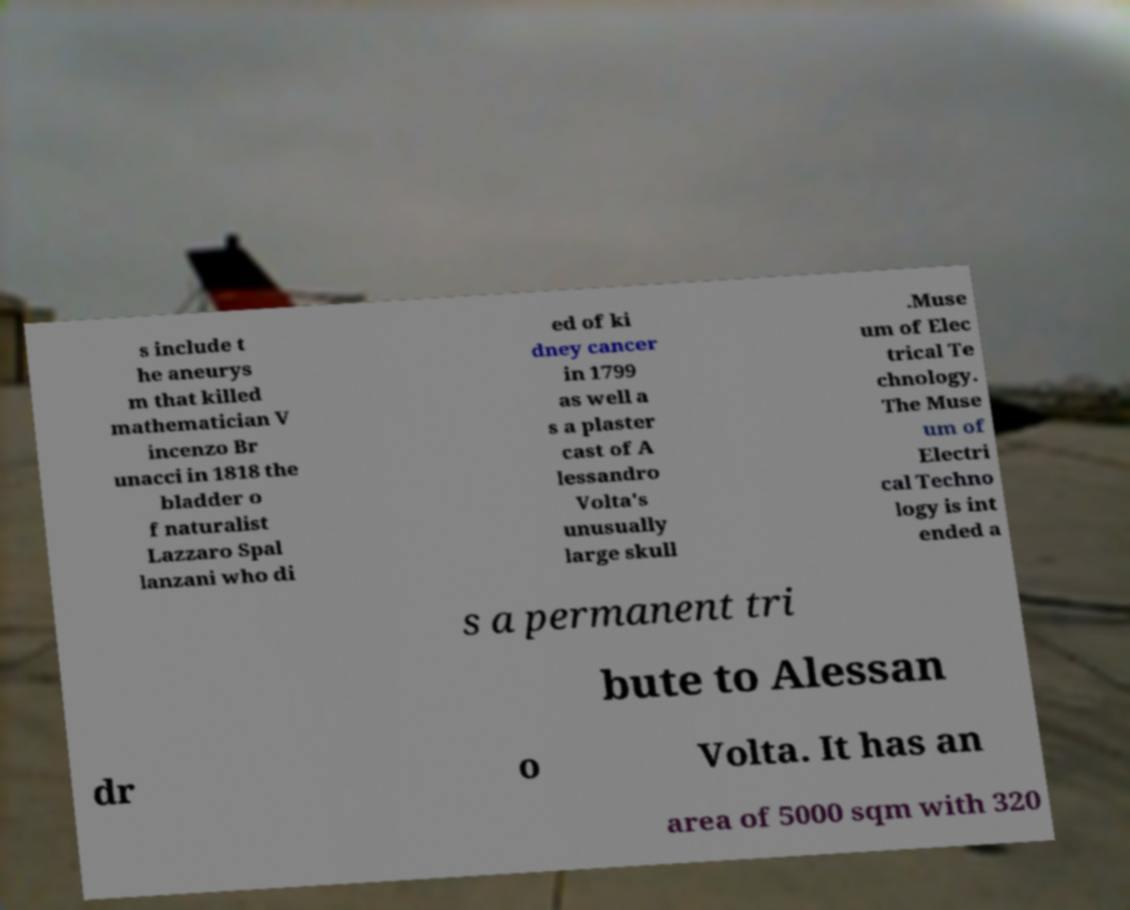Can you read and provide the text displayed in the image?This photo seems to have some interesting text. Can you extract and type it out for me? s include t he aneurys m that killed mathematician V incenzo Br unacci in 1818 the bladder o f naturalist Lazzaro Spal lanzani who di ed of ki dney cancer in 1799 as well a s a plaster cast of A lessandro Volta's unusually large skull .Muse um of Elec trical Te chnology. The Muse um of Electri cal Techno logy is int ended a s a permanent tri bute to Alessan dr o Volta. It has an area of 5000 sqm with 320 